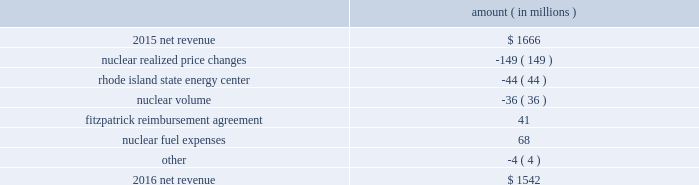Entergy corporation and subsidiaries management 2019s financial discussion and analysis combination .
Consistent with the terms of the stipulated settlement in the business combination proceeding , electric customers of entergy louisiana will realize customer credits associated with the business combination ; accordingly , in october 2015 , entergy recorded a regulatory liability of $ 107 million ( $ 66 million net-of-tax ) .
These costs are being amortized over a nine-year period beginning december 2015 .
See note 2 to the financial statements for further discussion of the business combination and customer credits .
The volume/weather variance is primarily due to the effect of more favorable weather during the unbilled period and an increase in industrial usage , partially offset by the effect of less favorable weather on residential sales .
The increase in industrial usage is primarily due to expansion projects , primarily in the chemicals industry , and increased demand from new customers , primarily in the industrial gases industry .
The louisiana act 55 financing savings obligation variance results from a regulatory charge for tax savings to be shared with customers per an agreement approved by the lpsc .
The tax savings results from the 2010-2011 irs audit settlement on the treatment of the louisiana act 55 financing of storm costs for hurricane gustav and hurricane ike .
See note 3 to the financial statements for additional discussion of the settlement and benefit sharing .
Included in other is a provision of $ 23 million recorded in 2016 related to the settlement of the waterford 3 replacement steam generator prudence review proceeding , offset by a provision of $ 32 million recorded in 2015 related to the uncertainty at that time associated with the resolution of the waterford 3 replacement steam generator prudence review proceeding .
See note 2 to the financial statements for a discussion of the waterford 3 replacement steam generator prudence review proceeding .
Entergy wholesale commodities following is an analysis of the change in net revenue comparing 2016 to 2015 .
Amount ( in millions ) .
As shown in the table above , net revenue for entergy wholesale commodities decreased by approximately $ 124 million in 2016 primarily due to : 2022 lower realized wholesale energy prices and lower capacity prices , although the average revenue per mwh shown in the table below for the nuclear fleet is slightly higher because it includes revenues from the fitzpatrick reimbursement agreement with exelon , the amortization of the palisades below-market ppa , and vermont yankee capacity revenue .
The effect of the amortization of the palisades below-market ppa and vermont yankee capacity revenue on the net revenue variance from 2015 to 2016 is minimal ; 2022 the sale of the rhode island state energy center in december 2015 .
See note 14 to the financial statements for further discussion of the rhode island state energy center sale ; and 2022 lower volume in the entergy wholesale commodities nuclear fleet resulting from more refueling outage days in 2016 as compared to 2015 and larger exercise of resupply options in 2016 as compared to 2015 .
See 201cnuclear .
What would net revenue have been in 2016 if there wasn't a gain from the fitzpatrick reimbursement agreement? 
Computations: (1542 - 41)
Answer: 1501.0. Entergy corporation and subsidiaries management 2019s financial discussion and analysis combination .
Consistent with the terms of the stipulated settlement in the business combination proceeding , electric customers of entergy louisiana will realize customer credits associated with the business combination ; accordingly , in october 2015 , entergy recorded a regulatory liability of $ 107 million ( $ 66 million net-of-tax ) .
These costs are being amortized over a nine-year period beginning december 2015 .
See note 2 to the financial statements for further discussion of the business combination and customer credits .
The volume/weather variance is primarily due to the effect of more favorable weather during the unbilled period and an increase in industrial usage , partially offset by the effect of less favorable weather on residential sales .
The increase in industrial usage is primarily due to expansion projects , primarily in the chemicals industry , and increased demand from new customers , primarily in the industrial gases industry .
The louisiana act 55 financing savings obligation variance results from a regulatory charge for tax savings to be shared with customers per an agreement approved by the lpsc .
The tax savings results from the 2010-2011 irs audit settlement on the treatment of the louisiana act 55 financing of storm costs for hurricane gustav and hurricane ike .
See note 3 to the financial statements for additional discussion of the settlement and benefit sharing .
Included in other is a provision of $ 23 million recorded in 2016 related to the settlement of the waterford 3 replacement steam generator prudence review proceeding , offset by a provision of $ 32 million recorded in 2015 related to the uncertainty at that time associated with the resolution of the waterford 3 replacement steam generator prudence review proceeding .
See note 2 to the financial statements for a discussion of the waterford 3 replacement steam generator prudence review proceeding .
Entergy wholesale commodities following is an analysis of the change in net revenue comparing 2016 to 2015 .
Amount ( in millions ) .
As shown in the table above , net revenue for entergy wholesale commodities decreased by approximately $ 124 million in 2016 primarily due to : 2022 lower realized wholesale energy prices and lower capacity prices , although the average revenue per mwh shown in the table below for the nuclear fleet is slightly higher because it includes revenues from the fitzpatrick reimbursement agreement with exelon , the amortization of the palisades below-market ppa , and vermont yankee capacity revenue .
The effect of the amortization of the palisades below-market ppa and vermont yankee capacity revenue on the net revenue variance from 2015 to 2016 is minimal ; 2022 the sale of the rhode island state energy center in december 2015 .
See note 14 to the financial statements for further discussion of the rhode island state energy center sale ; and 2022 lower volume in the entergy wholesale commodities nuclear fleet resulting from more refueling outage days in 2016 as compared to 2015 and larger exercise of resupply options in 2016 as compared to 2015 .
See 201cnuclear .
What would the net revenue have been in 2015 if there wasn't a stipulated settlement from the business combination in october 2015? 
Computations: (66 + 1666)
Answer: 1732.0. 